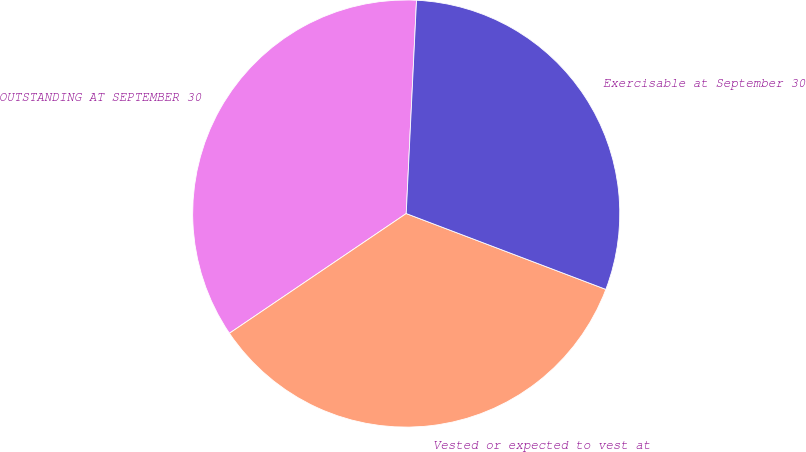Convert chart to OTSL. <chart><loc_0><loc_0><loc_500><loc_500><pie_chart><fcel>OUTSTANDING AT SEPTEMBER 30<fcel>Vested or expected to vest at<fcel>Exercisable at September 30<nl><fcel>35.24%<fcel>34.75%<fcel>30.01%<nl></chart> 